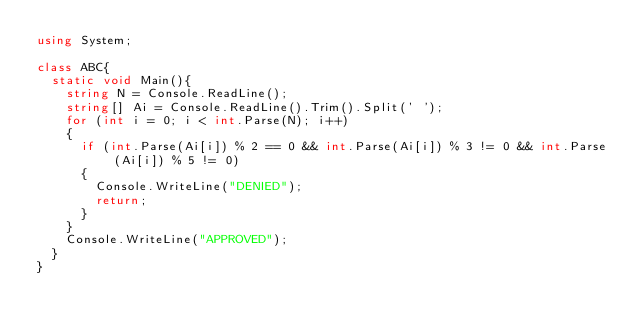<code> <loc_0><loc_0><loc_500><loc_500><_C#_>using System;

class ABC{
  static void Main(){
    string N = Console.ReadLine();
    string[] Ai = Console.ReadLine().Trim().Split(' ');
    for (int i = 0; i < int.Parse(N); i++)
    {
      if (int.Parse(Ai[i]) % 2 == 0 && int.Parse(Ai[i]) % 3 != 0 && int.Parse(Ai[i]) % 5 != 0)
      {
        Console.WriteLine("DENIED");
        return;
      }
    }
    Console.WriteLine("APPROVED");
  }
}
</code> 